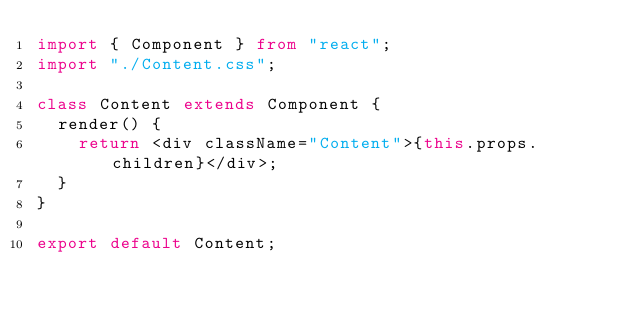<code> <loc_0><loc_0><loc_500><loc_500><_TypeScript_>import { Component } from "react";
import "./Content.css";

class Content extends Component {
  render() {
    return <div className="Content">{this.props.children}</div>;
  }
}

export default Content;
</code> 